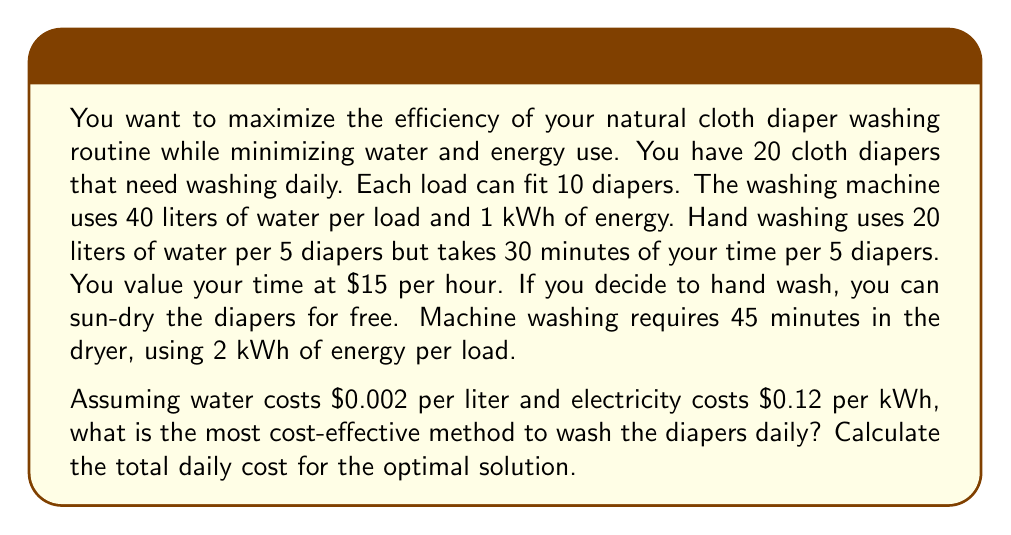Teach me how to tackle this problem. Let's break this down step-by-step:

1) Machine washing:
   - Number of loads: $\frac{20 \text{ diapers}}{10 \text{ diapers per load}} = 2 \text{ loads}$
   - Water usage: $2 \times 40 = 80 \text{ liters}$
   - Water cost: $80 \times $0.002 = $0.16
   - Washing energy: $2 \times 1 \text{ kWh} = 2 \text{ kWh}$
   - Drying energy: $2 \times 2 \text{ kWh} = 4 \text{ kWh}$
   - Total energy: $6 \text{ kWh}$
   - Energy cost: $6 \times $0.12 = $0.72
   - Total machine cost: $0.16 + $0.72 = $0.88

2) Hand washing:
   - Number of batches: $\frac{20 \text{ diapers}}{5 \text{ diapers per batch}} = 4 \text{ batches}$
   - Water usage: $4 \times 20 = 80 \text{ liters}$
   - Water cost: $80 \times $0.002 = $0.16
   - Time required: $4 \times 30 \text{ minutes} = 120 \text{ minutes} = 2 \text{ hours}$
   - Labor cost: $2 \times $15 = $30
   - Total hand washing cost: $0.16 + $30 = $30.16

3) Hybrid approach:
   Let $x$ be the number of diapers machine washed, and $(20-x)$ be hand washed.
   
   Total cost: $C(x) = (\text{machine cost per diaper} \times x) + (\text{hand wash cost per diaper} \times (20-x))$
   
   $C(x) = (\frac{$0.88}{20} \times x) + (\frac{$30.16}{20} \times (20-x))$
   
   $C(x) = 0.044x + 30.16 - 1.508x = 30.16 - 1.464x$
   
   This is a linear function, so the minimum will be at one of the extremes.
   
   $C(0) = $30.16 (all hand washed)
   $C(20) = $0.88 (all machine washed)

Therefore, the most cost-effective method is to machine wash all diapers.
Answer: The most cost-effective method is to machine wash all 20 diapers daily. The total daily cost for this optimal solution is $0.88. 